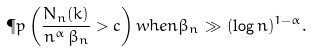<formula> <loc_0><loc_0><loc_500><loc_500>\P p \left ( \frac { N _ { n } ( k ) } { n ^ { \alpha } \, \beta _ { n } } > c \right ) w h e n \beta _ { n } \gg ( \log n ) ^ { 1 - \alpha } .</formula> 